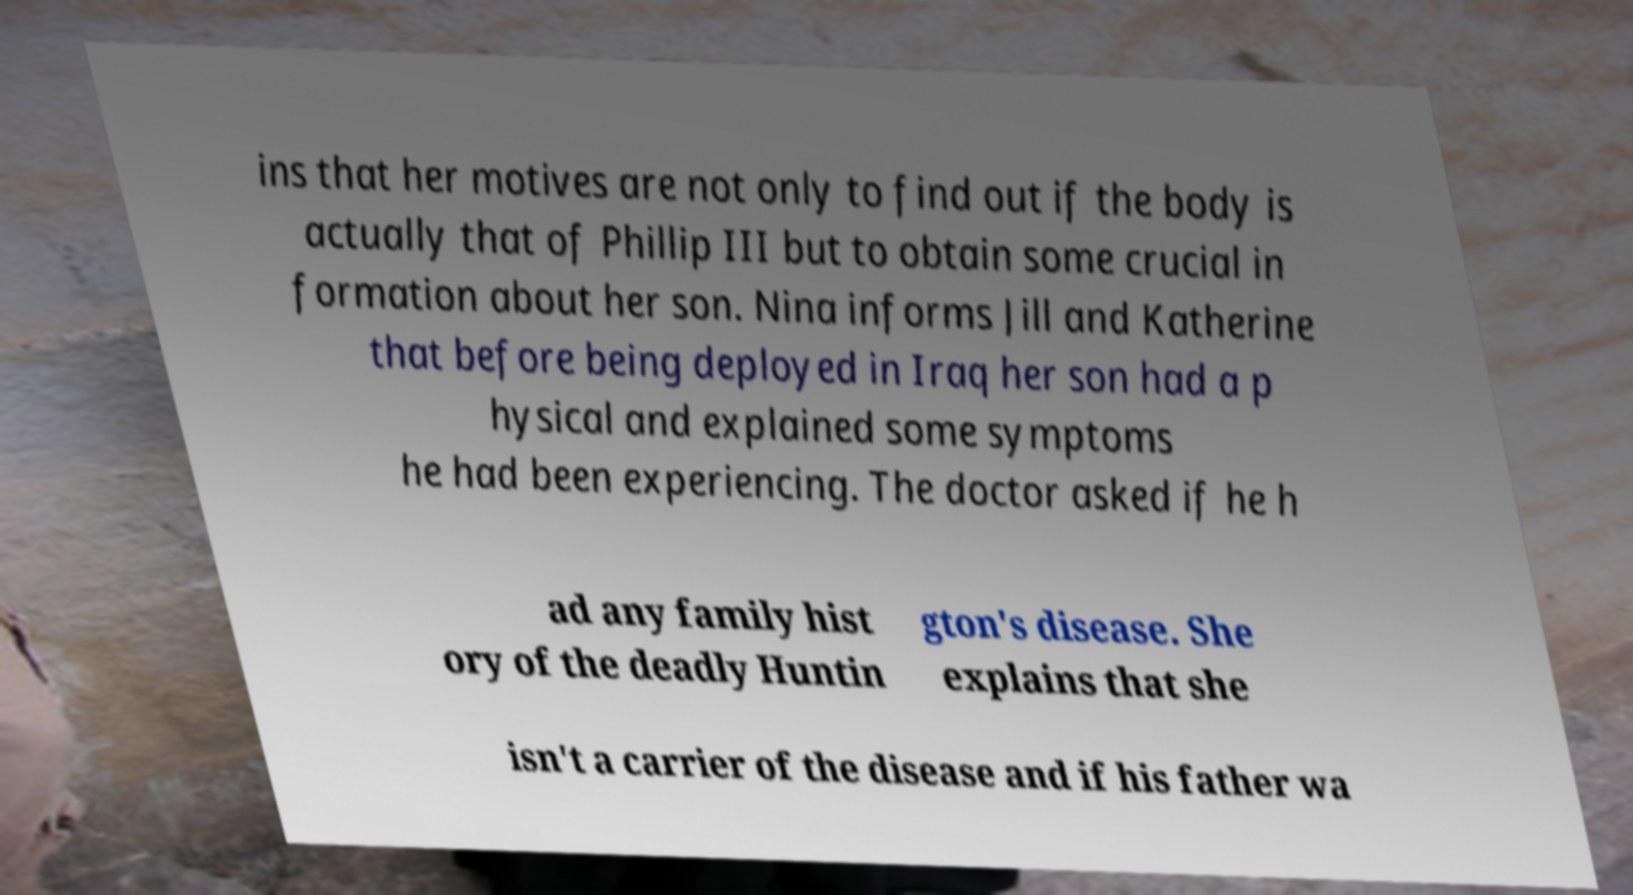Can you accurately transcribe the text from the provided image for me? ins that her motives are not only to find out if the body is actually that of Phillip III but to obtain some crucial in formation about her son. Nina informs Jill and Katherine that before being deployed in Iraq her son had a p hysical and explained some symptoms he had been experiencing. The doctor asked if he h ad any family hist ory of the deadly Huntin gton's disease. She explains that she isn't a carrier of the disease and if his father wa 